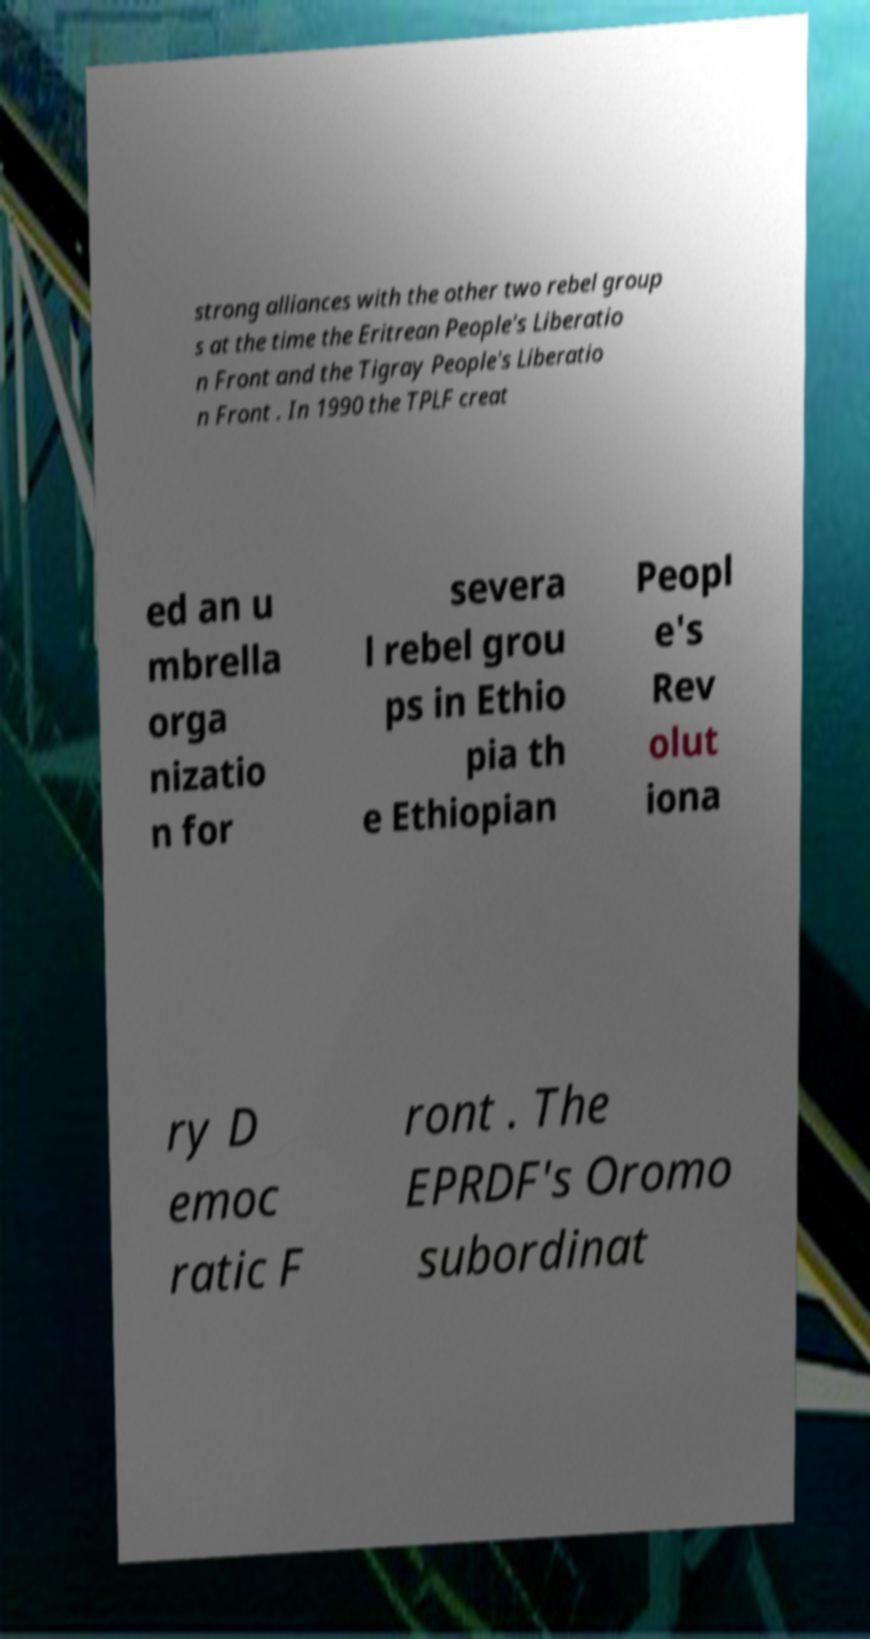I need the written content from this picture converted into text. Can you do that? strong alliances with the other two rebel group s at the time the Eritrean People's Liberatio n Front and the Tigray People's Liberatio n Front . In 1990 the TPLF creat ed an u mbrella orga nizatio n for severa l rebel grou ps in Ethio pia th e Ethiopian Peopl e's Rev olut iona ry D emoc ratic F ront . The EPRDF's Oromo subordinat 